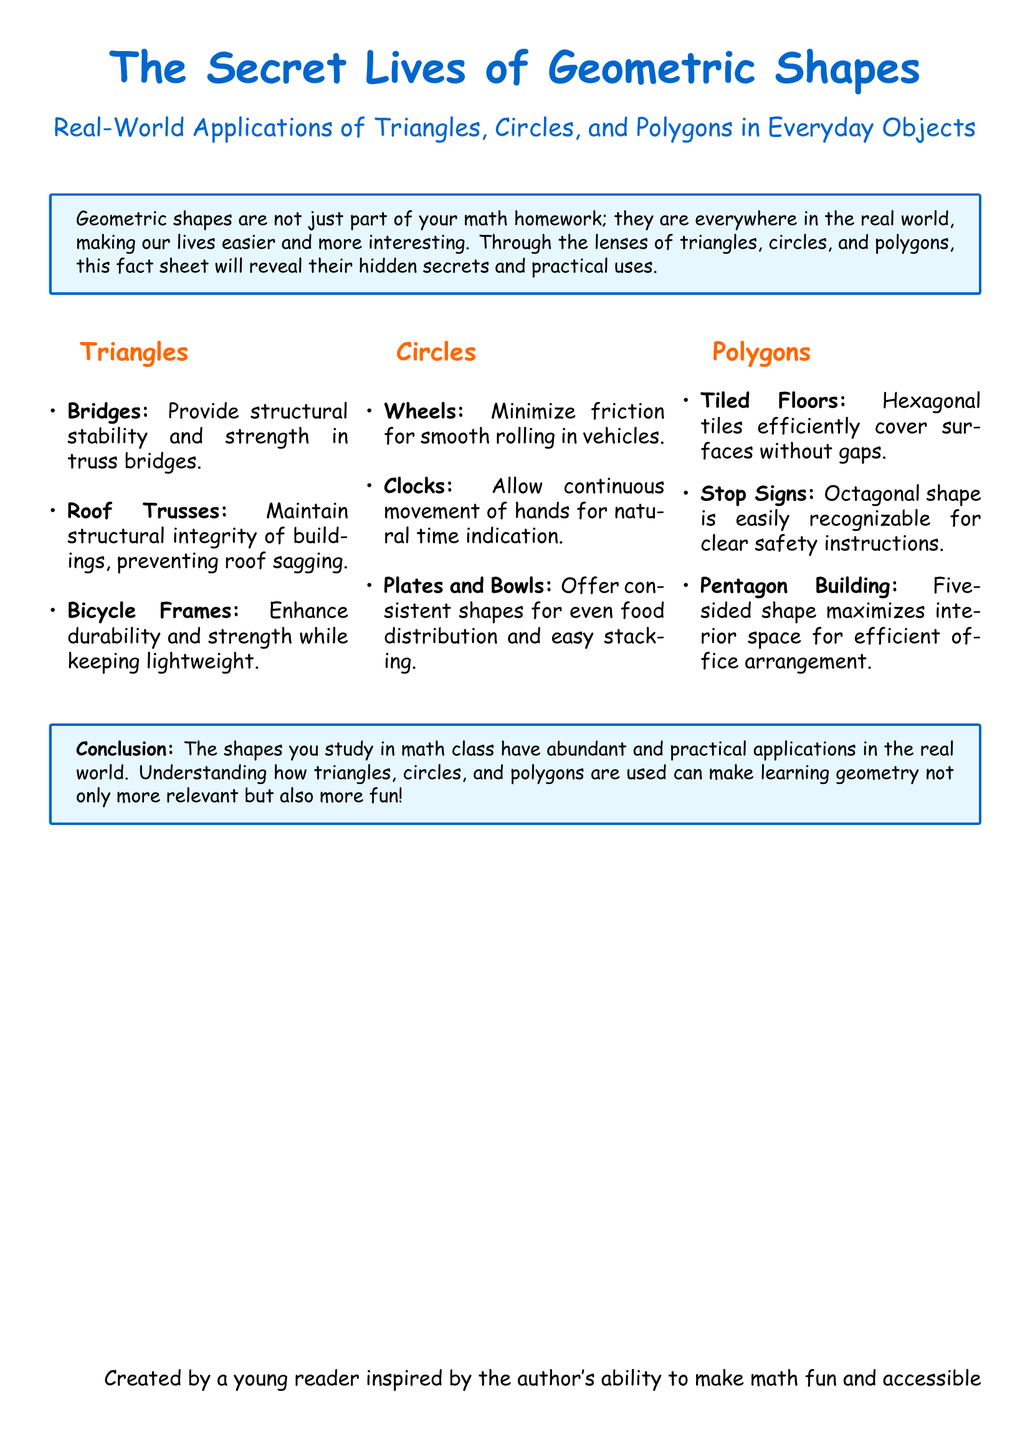What is the title of the document? The title is prominently displayed at the top of the document and is "The Secret Lives of Geometric Shapes."
Answer: The Secret Lives of Geometric Shapes What are the three types of geometric shapes discussed? The three shapes are listed in their respective sections, which are triangles, circles, and polygons.
Answer: Triangles, Circles, and Polygons Which geometric shape is used to enhance the durability of bicycles? The answer is found in the section about triangles, which mentions their use in bicycle frames.
Answer: Triangles What shape is a stop sign? The document describes the shape used for stop signs, which is noted in the polygons section.
Answer: Octagonal What is the main application of circles in clocks? This information can be found in the circles section, where it discusses how circles function in clocks.
Answer: Continuous movement Why are hexagonal tiles efficient for tiled floors? The reasoning is provided in the polygons section, explaining their unique ability to cover surfaces.
Answer: Without gaps How does the author suggest learning geometry can be made more enjoyable? The conclusion of the document summarizes the author's viewpoint on the relevance of shapes learned in math.
Answer: More relevant and fun What color is used for the title text in the document? The color used for the title text is specified at the beginning where the document design is described.
Answer: RGB(0,102,204) 